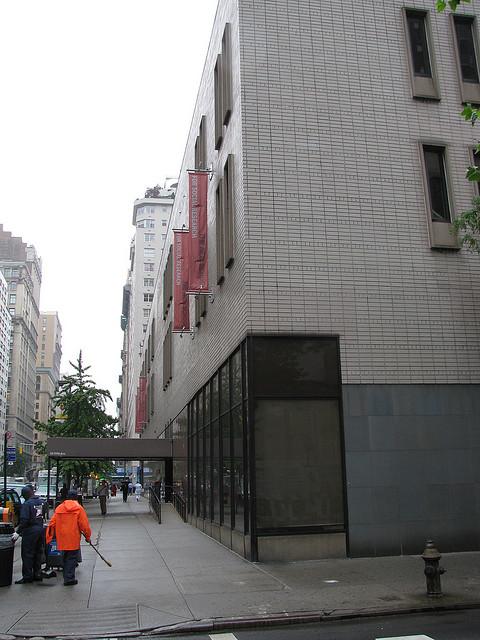How many flags are there?
Keep it brief. 0. What color is the woman wearing?
Answer briefly. Orange. Is the building in the foreground a store?
Keep it brief. Yes. What is wrong with the wall?
Give a very brief answer. Nothing. How many are in the photo?
Answer briefly. 2. How many people are walking on the street?
Concise answer only. 3. How old is this building?
Give a very brief answer. Old. How many people are wearing white?
Give a very brief answer. 0. What is the man in orange doing?
Give a very brief answer. Walking. 